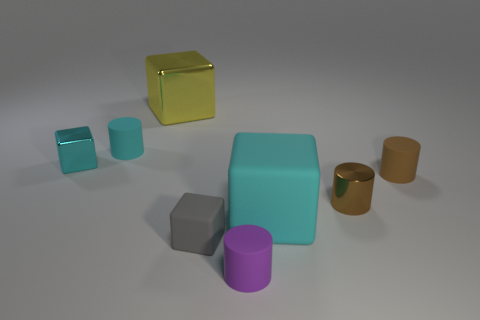Is the color of the large object that is to the right of the yellow block the same as the big metallic block?
Offer a very short reply. No. There is a matte object left of the small gray cube; does it have the same size as the metallic block that is to the right of the tiny cyan block?
Offer a very short reply. No. What is the size of the brown object that is the same material as the purple cylinder?
Your answer should be compact. Small. What number of metallic things are to the right of the tiny cyan metallic object and in front of the large yellow cube?
Give a very brief answer. 1. How many things are either purple things or rubber things that are on the left side of the large cyan rubber thing?
Your response must be concise. 3. There is a tiny metal object that is the same color as the large matte cube; what is its shape?
Your response must be concise. Cube. There is a small shiny thing in front of the tiny cyan block; what is its color?
Your answer should be compact. Brown. How many objects are either rubber things to the right of the tiny brown shiny cylinder or purple matte cylinders?
Your answer should be very brief. 2. There is a shiny cylinder that is the same size as the gray cube; what is its color?
Your response must be concise. Brown. Is the number of cyan matte things that are behind the metallic cylinder greater than the number of tiny blue metallic objects?
Make the answer very short. Yes. 